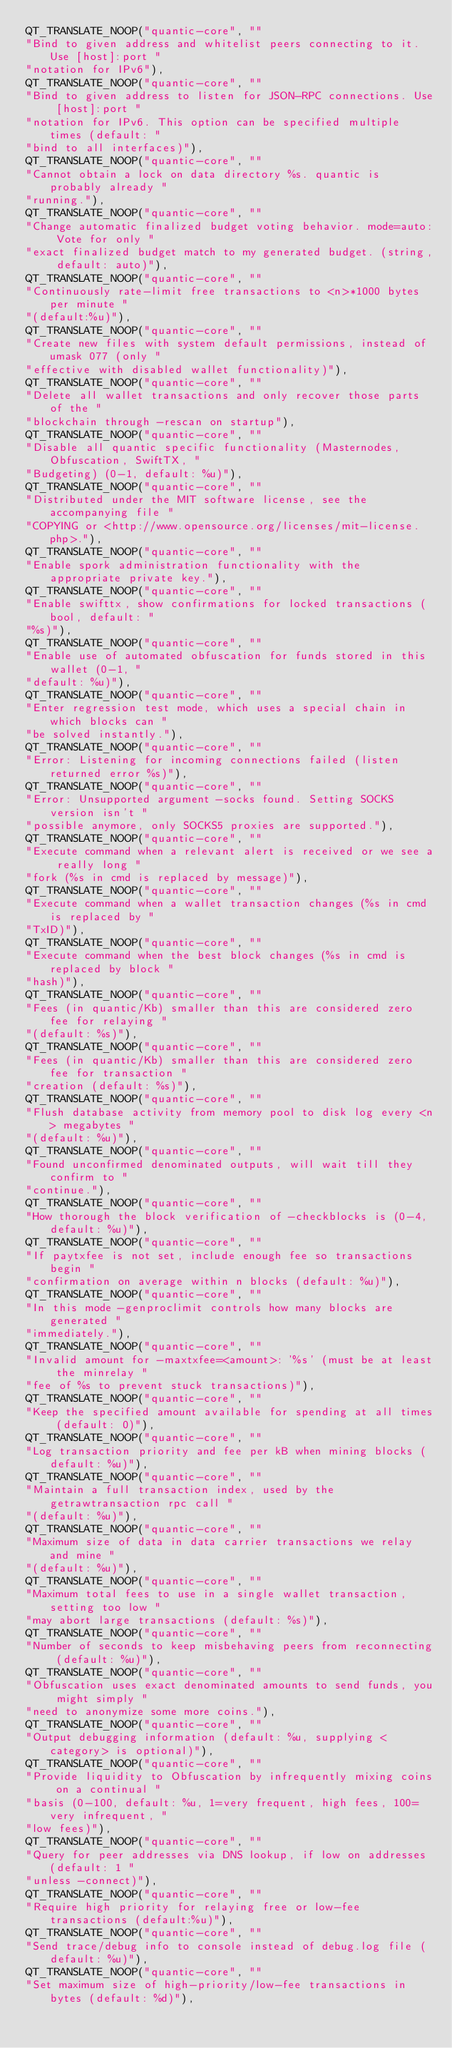<code> <loc_0><loc_0><loc_500><loc_500><_C++_>QT_TRANSLATE_NOOP("quantic-core", ""
"Bind to given address and whitelist peers connecting to it. Use [host]:port "
"notation for IPv6"),
QT_TRANSLATE_NOOP("quantic-core", ""
"Bind to given address to listen for JSON-RPC connections. Use [host]:port "
"notation for IPv6. This option can be specified multiple times (default: "
"bind to all interfaces)"),
QT_TRANSLATE_NOOP("quantic-core", ""
"Cannot obtain a lock on data directory %s. quantic is probably already "
"running."),
QT_TRANSLATE_NOOP("quantic-core", ""
"Change automatic finalized budget voting behavior. mode=auto: Vote for only "
"exact finalized budget match to my generated budget. (string, default: auto)"),
QT_TRANSLATE_NOOP("quantic-core", ""
"Continuously rate-limit free transactions to <n>*1000 bytes per minute "
"(default:%u)"),
QT_TRANSLATE_NOOP("quantic-core", ""
"Create new files with system default permissions, instead of umask 077 (only "
"effective with disabled wallet functionality)"),
QT_TRANSLATE_NOOP("quantic-core", ""
"Delete all wallet transactions and only recover those parts of the "
"blockchain through -rescan on startup"),
QT_TRANSLATE_NOOP("quantic-core", ""
"Disable all quantic specific functionality (Masternodes, Obfuscation, SwiftTX, "
"Budgeting) (0-1, default: %u)"),
QT_TRANSLATE_NOOP("quantic-core", ""
"Distributed under the MIT software license, see the accompanying file "
"COPYING or <http://www.opensource.org/licenses/mit-license.php>."),
QT_TRANSLATE_NOOP("quantic-core", ""
"Enable spork administration functionality with the appropriate private key."),
QT_TRANSLATE_NOOP("quantic-core", ""
"Enable swifttx, show confirmations for locked transactions (bool, default: "
"%s)"),
QT_TRANSLATE_NOOP("quantic-core", ""
"Enable use of automated obfuscation for funds stored in this wallet (0-1, "
"default: %u)"),
QT_TRANSLATE_NOOP("quantic-core", ""
"Enter regression test mode, which uses a special chain in which blocks can "
"be solved instantly."),
QT_TRANSLATE_NOOP("quantic-core", ""
"Error: Listening for incoming connections failed (listen returned error %s)"),
QT_TRANSLATE_NOOP("quantic-core", ""
"Error: Unsupported argument -socks found. Setting SOCKS version isn't "
"possible anymore, only SOCKS5 proxies are supported."),
QT_TRANSLATE_NOOP("quantic-core", ""
"Execute command when a relevant alert is received or we see a really long "
"fork (%s in cmd is replaced by message)"),
QT_TRANSLATE_NOOP("quantic-core", ""
"Execute command when a wallet transaction changes (%s in cmd is replaced by "
"TxID)"),
QT_TRANSLATE_NOOP("quantic-core", ""
"Execute command when the best block changes (%s in cmd is replaced by block "
"hash)"),
QT_TRANSLATE_NOOP("quantic-core", ""
"Fees (in quantic/Kb) smaller than this are considered zero fee for relaying "
"(default: %s)"),
QT_TRANSLATE_NOOP("quantic-core", ""
"Fees (in quantic/Kb) smaller than this are considered zero fee for transaction "
"creation (default: %s)"),
QT_TRANSLATE_NOOP("quantic-core", ""
"Flush database activity from memory pool to disk log every <n> megabytes "
"(default: %u)"),
QT_TRANSLATE_NOOP("quantic-core", ""
"Found unconfirmed denominated outputs, will wait till they confirm to "
"continue."),
QT_TRANSLATE_NOOP("quantic-core", ""
"How thorough the block verification of -checkblocks is (0-4, default: %u)"),
QT_TRANSLATE_NOOP("quantic-core", ""
"If paytxfee is not set, include enough fee so transactions begin "
"confirmation on average within n blocks (default: %u)"),
QT_TRANSLATE_NOOP("quantic-core", ""
"In this mode -genproclimit controls how many blocks are generated "
"immediately."),
QT_TRANSLATE_NOOP("quantic-core", ""
"Invalid amount for -maxtxfee=<amount>: '%s' (must be at least the minrelay "
"fee of %s to prevent stuck transactions)"),
QT_TRANSLATE_NOOP("quantic-core", ""
"Keep the specified amount available for spending at all times (default: 0)"),
QT_TRANSLATE_NOOP("quantic-core", ""
"Log transaction priority and fee per kB when mining blocks (default: %u)"),
QT_TRANSLATE_NOOP("quantic-core", ""
"Maintain a full transaction index, used by the getrawtransaction rpc call "
"(default: %u)"),
QT_TRANSLATE_NOOP("quantic-core", ""
"Maximum size of data in data carrier transactions we relay and mine "
"(default: %u)"),
QT_TRANSLATE_NOOP("quantic-core", ""
"Maximum total fees to use in a single wallet transaction, setting too low "
"may abort large transactions (default: %s)"),
QT_TRANSLATE_NOOP("quantic-core", ""
"Number of seconds to keep misbehaving peers from reconnecting (default: %u)"),
QT_TRANSLATE_NOOP("quantic-core", ""
"Obfuscation uses exact denominated amounts to send funds, you might simply "
"need to anonymize some more coins."),
QT_TRANSLATE_NOOP("quantic-core", ""
"Output debugging information (default: %u, supplying <category> is optional)"),
QT_TRANSLATE_NOOP("quantic-core", ""
"Provide liquidity to Obfuscation by infrequently mixing coins on a continual "
"basis (0-100, default: %u, 1=very frequent, high fees, 100=very infrequent, "
"low fees)"),
QT_TRANSLATE_NOOP("quantic-core", ""
"Query for peer addresses via DNS lookup, if low on addresses (default: 1 "
"unless -connect)"),
QT_TRANSLATE_NOOP("quantic-core", ""
"Require high priority for relaying free or low-fee transactions (default:%u)"),
QT_TRANSLATE_NOOP("quantic-core", ""
"Send trace/debug info to console instead of debug.log file (default: %u)"),
QT_TRANSLATE_NOOP("quantic-core", ""
"Set maximum size of high-priority/low-fee transactions in bytes (default: %d)"),</code> 